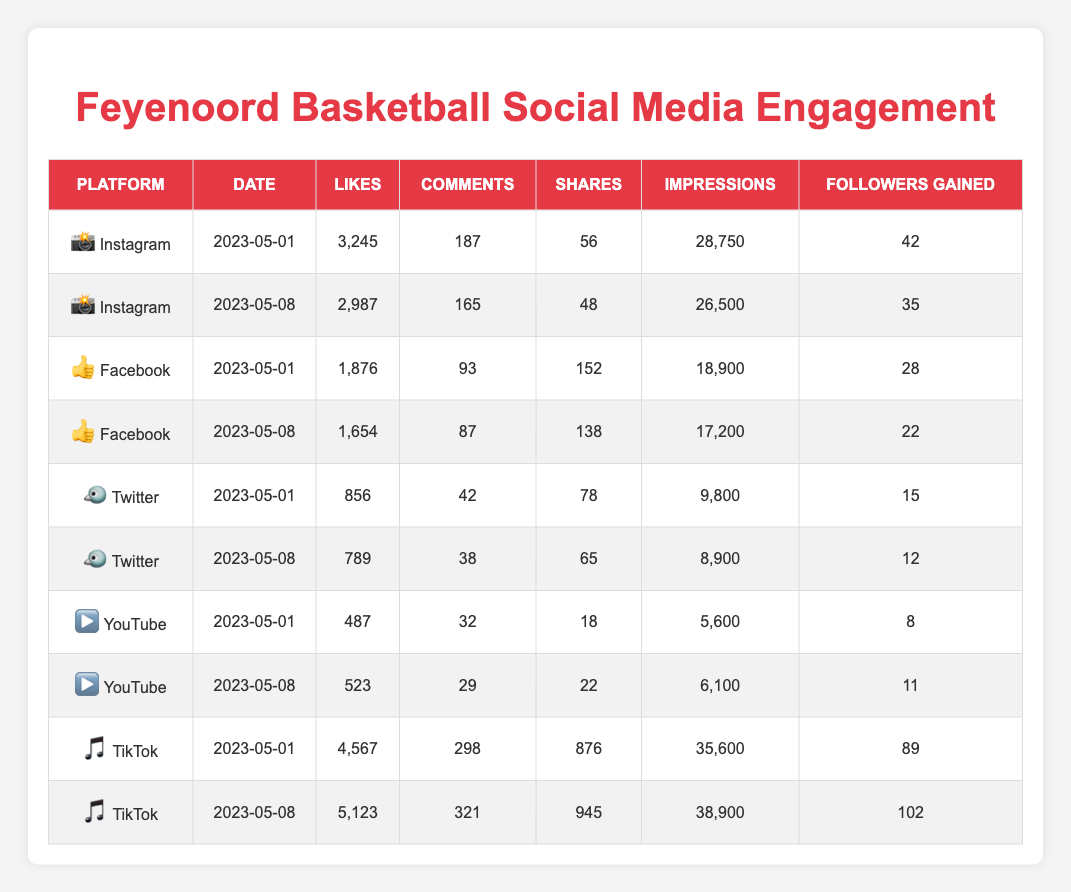What's the total number of likes on Instagram for the two dates listed? The likes on Instagram for the dates are 3,245 (on May 1) and 2,987 (on May 8). Adding these values gives us 3,245 + 2,987 = 6,232.
Answer: 6,232 Which platform generated the highest number of shares on May 1, 2023? Looking at the shares on May 1, Instagram has 56 shares, Facebook has 152, Twitter has 78, YouTube has 18, and TikTok has 876. The highest number of shares is from TikTok with 876.
Answer: TikTok What was the engagement (likes + comments + shares) for the Feyenoord Basketball's Facebook account on May 8? On May 8, the Facebook account had 1,654 likes, 87 comments, and 138 shares. The total engagement is 1,654 + 87 + 138 = 1,879.
Answer: 1,879 Did Feyenoord Basketball gain more followers on TikTok on May 8 than on Twitter on the same date? On TikTok, the followers gained on May 8 are 102, and on Twitter, they gained 12. Since 102 > 12, it can be confirmed that they gained more followers on TikTok.
Answer: Yes What is the average number of likes across all platforms for both dates? First, we sum the likes for each entry: (3,245 + 2,987 + 1,876 + 1,654 + 856 + 789 + 487 + 523 + 4,567 + 5,123) = 22,021. There are 10 entries in total, so the average is 22,021 / 10 = 2,202.1, rounded gives us 2,202.
Answer: 2,202 On which platform did Feyenoord gain the least followers on May 1? Looking at May 1, the followers gained were 42 on Instagram, 28 on Facebook, 15 on Twitter, 8 on YouTube, and 89 on TikTok. The least followers gained is from YouTube with 8.
Answer: YouTube What was the total number of impressions on TikTok over the two dates? For TikTok, the impressions are 35,600 on May 1 and 38,900 on May 8. The total impressions are 35,600 + 38,900 = 74,500.
Answer: 74,500 Is the number of likes higher on TikTok on May 8 than on Instagram on the same date? On May 8, TikTok had 5,123 likes while Instagram had 2,987 likes. Since 5,123 > 2,987, TikTok had more likes than Instagram on that date.
Answer: Yes 